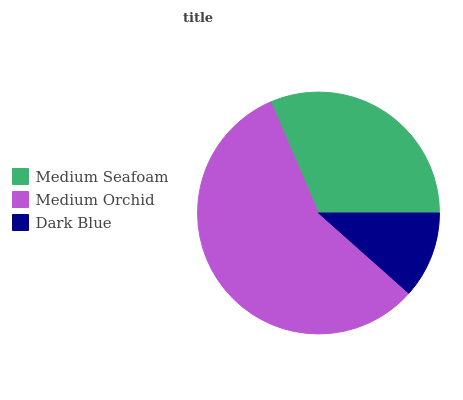Is Dark Blue the minimum?
Answer yes or no. Yes. Is Medium Orchid the maximum?
Answer yes or no. Yes. Is Medium Orchid the minimum?
Answer yes or no. No. Is Dark Blue the maximum?
Answer yes or no. No. Is Medium Orchid greater than Dark Blue?
Answer yes or no. Yes. Is Dark Blue less than Medium Orchid?
Answer yes or no. Yes. Is Dark Blue greater than Medium Orchid?
Answer yes or no. No. Is Medium Orchid less than Dark Blue?
Answer yes or no. No. Is Medium Seafoam the high median?
Answer yes or no. Yes. Is Medium Seafoam the low median?
Answer yes or no. Yes. Is Dark Blue the high median?
Answer yes or no. No. Is Medium Orchid the low median?
Answer yes or no. No. 